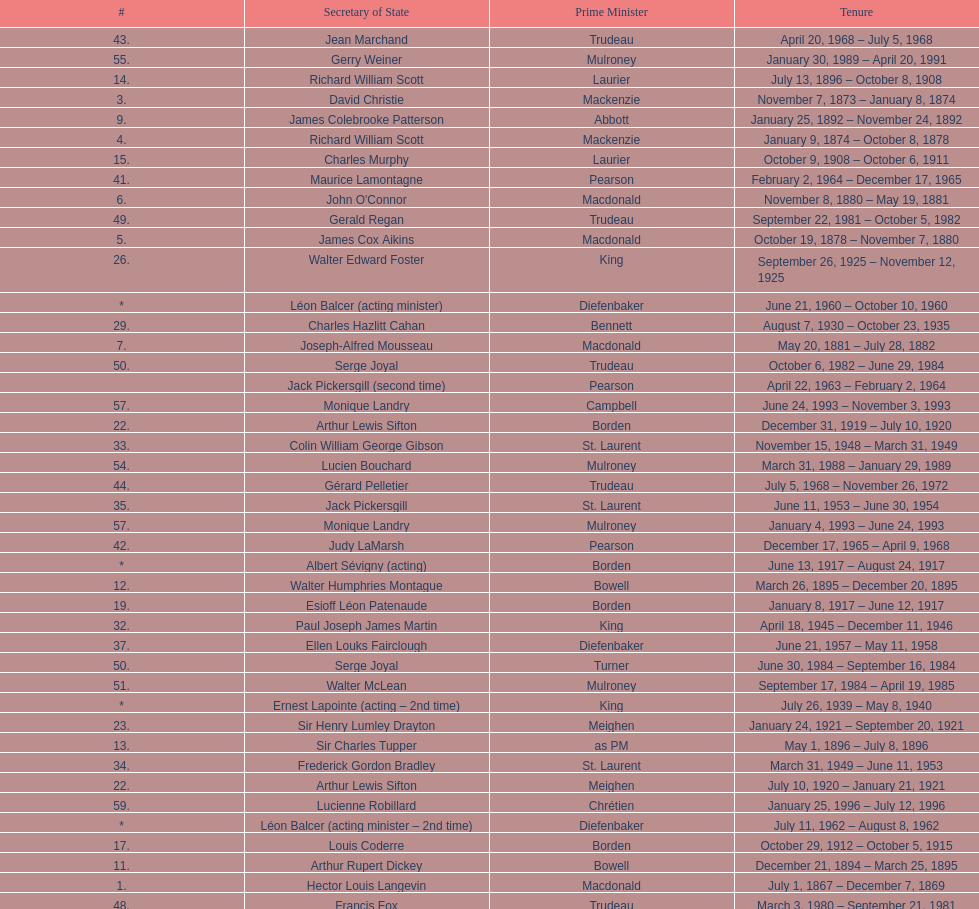What secretary of state served under both prime minister laurier and prime minister king? Charles Murphy. 